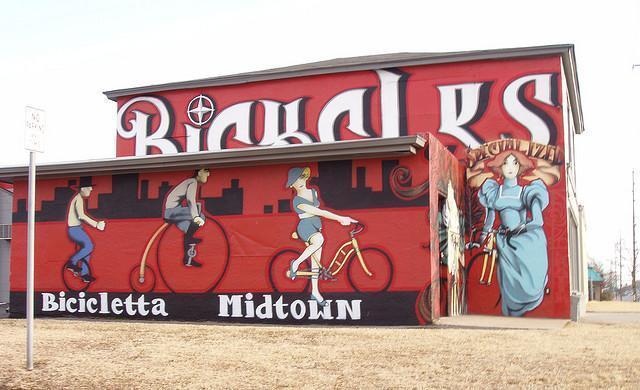How many people are visible?
Give a very brief answer. 3. How many bicycles are there?
Give a very brief answer. 2. 